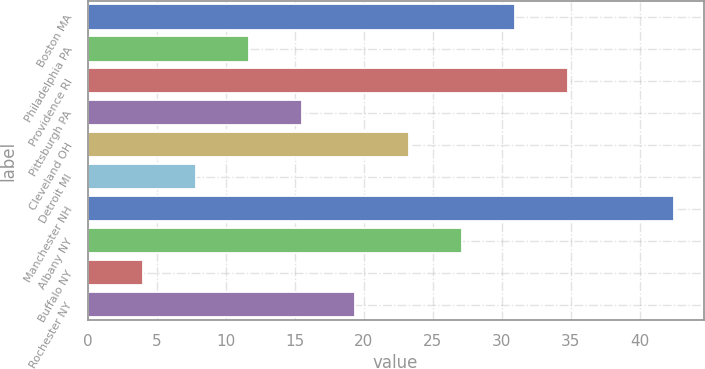Convert chart. <chart><loc_0><loc_0><loc_500><loc_500><bar_chart><fcel>Boston MA<fcel>Philadelphia PA<fcel>Providence RI<fcel>Pittsburgh PA<fcel>Cleveland OH<fcel>Detroit MI<fcel>Manchester NH<fcel>Albany NY<fcel>Buffalo NY<fcel>Rochester NY<nl><fcel>30.95<fcel>11.7<fcel>34.8<fcel>15.55<fcel>23.25<fcel>7.85<fcel>42.5<fcel>27.1<fcel>4<fcel>19.4<nl></chart> 